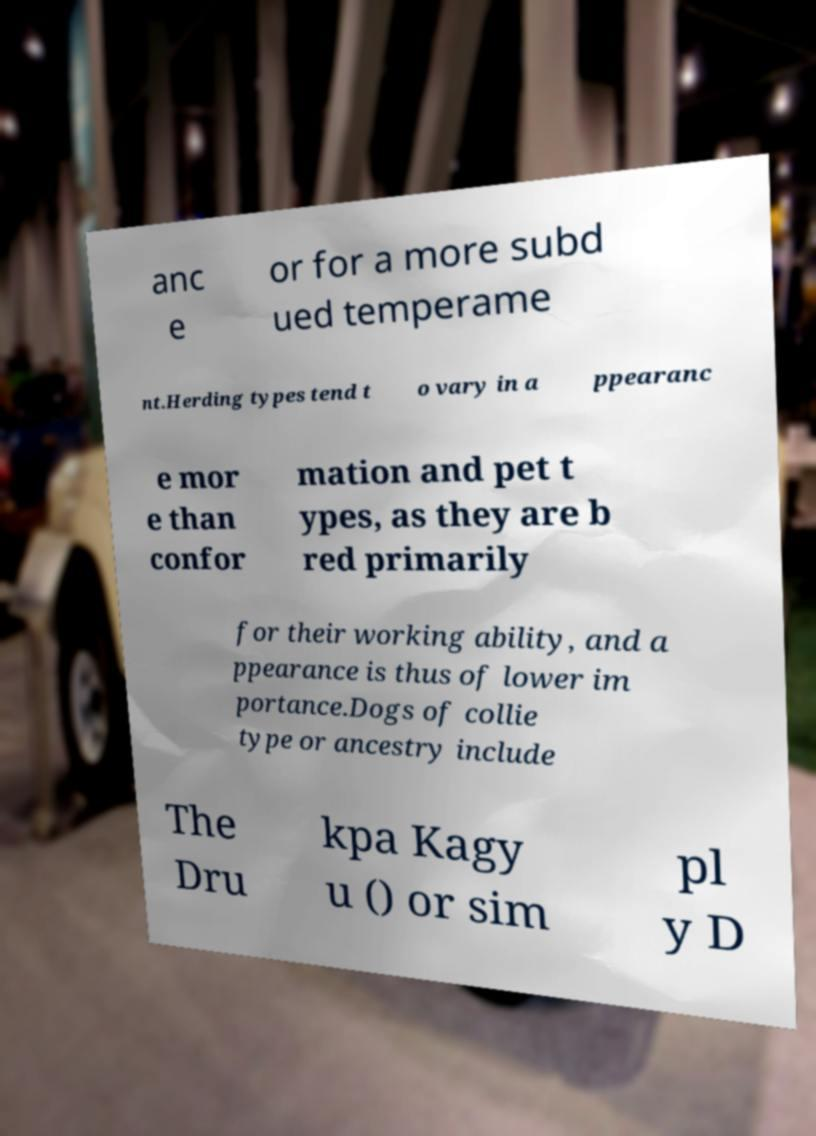I need the written content from this picture converted into text. Can you do that? anc e or for a more subd ued temperame nt.Herding types tend t o vary in a ppearanc e mor e than confor mation and pet t ypes, as they are b red primarily for their working ability, and a ppearance is thus of lower im portance.Dogs of collie type or ancestry include The Dru kpa Kagy u () or sim pl y D 